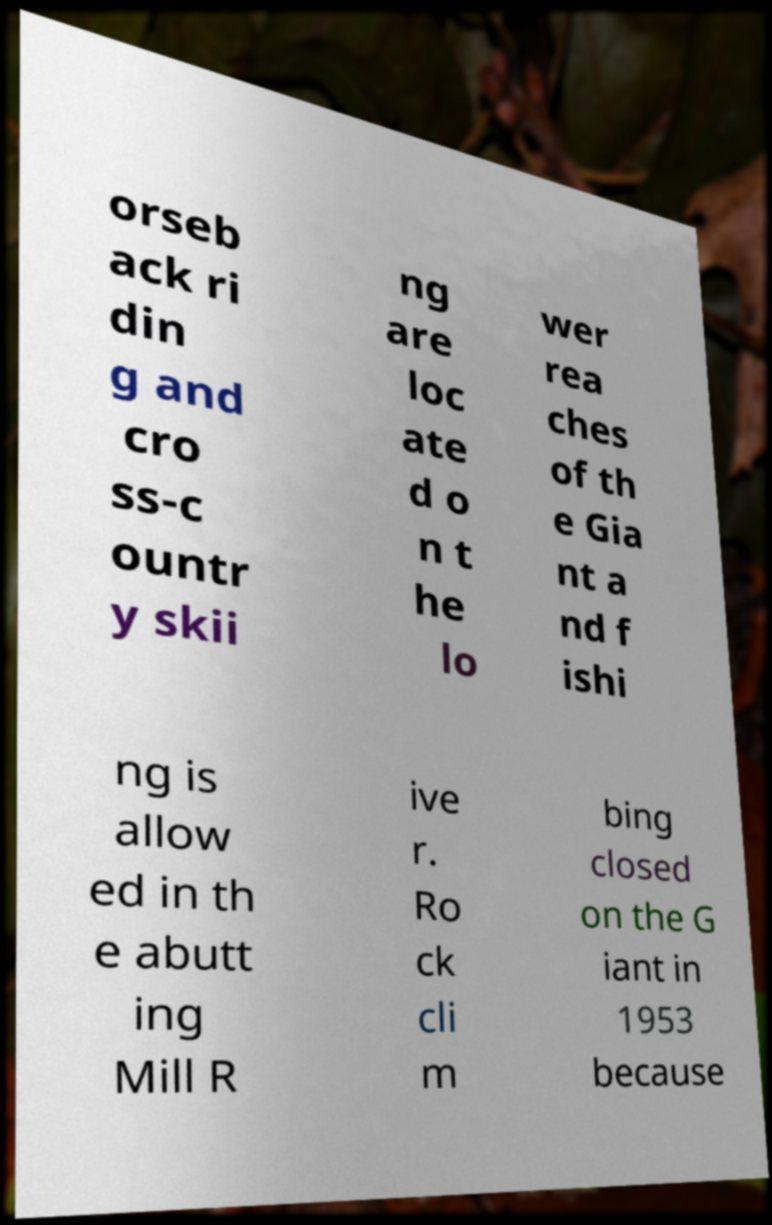There's text embedded in this image that I need extracted. Can you transcribe it verbatim? orseb ack ri din g and cro ss-c ountr y skii ng are loc ate d o n t he lo wer rea ches of th e Gia nt a nd f ishi ng is allow ed in th e abutt ing Mill R ive r. Ro ck cli m bing closed on the G iant in 1953 because 